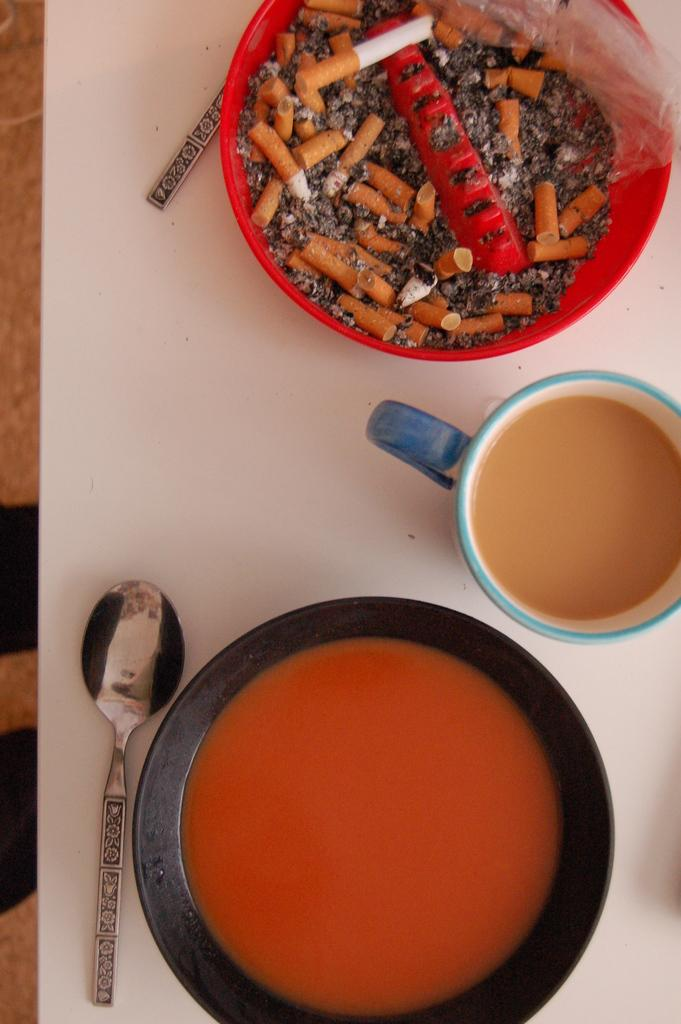What type of view is shown in the image? The image is a top view. What is in the bowl that is visible in the image? There is a bowl with soup in the image. What utensils can be seen in the image? There are spoons in the image. What else is in a container in the image? There is a cup with a drink in the image. What is in the other bowl in the image? There is a bowl with cigarette ashes in the image. What color is the table in the image? The table in the image is white. What type of knee control can be seen in the image? There is no knee control present in the image. 